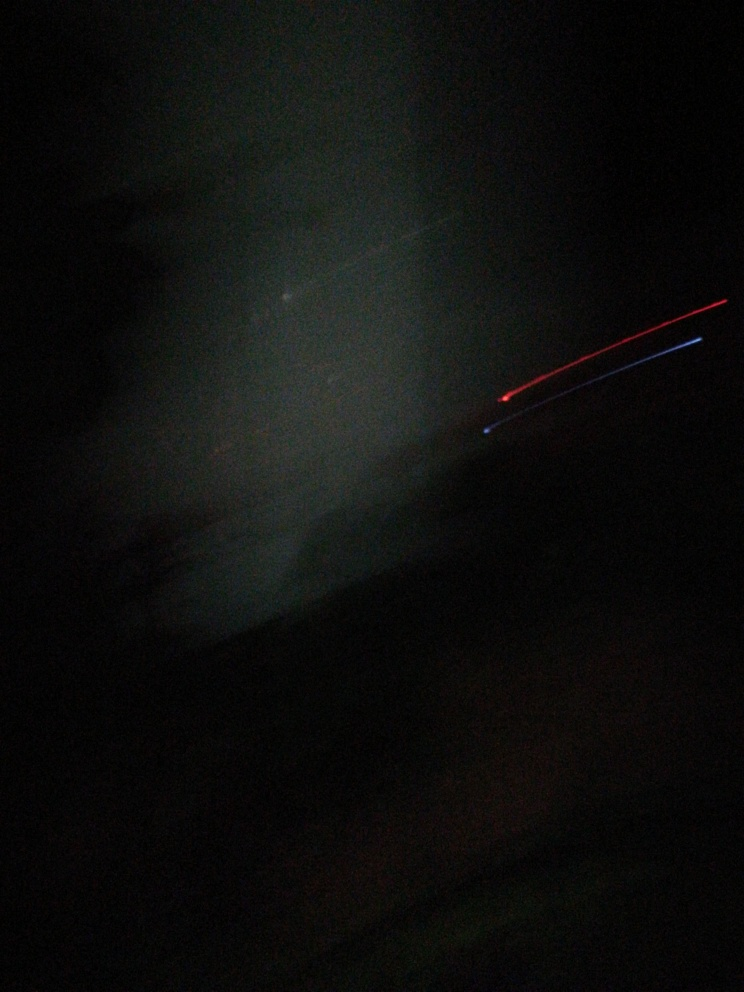Could this image be considered a successful example of abstract photography, and why? This image could be interpreted as an example of abstract photography, as it emphasizes colors, shapes, and forms over realistic representation. The darkness and light streaks create a sense of mystery and motion, which are qualities appreciated in abstract art. However, whether it's successful depends on the intent of the photographer and the viewer's personal taste. 